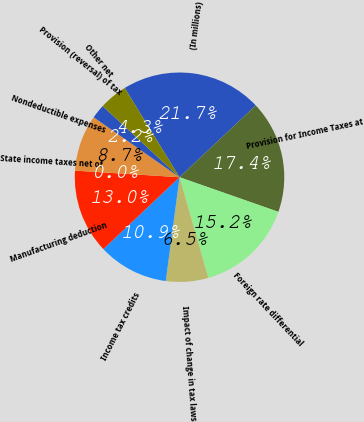Convert chart. <chart><loc_0><loc_0><loc_500><loc_500><pie_chart><fcel>(In millions)<fcel>Provision for Income Taxes at<fcel>Foreign rate differential<fcel>Impact of change in tax laws<fcel>Income tax credits<fcel>Manufacturing deduction<fcel>State income taxes net of<fcel>Nondeductible expenses<fcel>Provision (reversal) of tax<fcel>Other net<nl><fcel>21.74%<fcel>17.39%<fcel>15.22%<fcel>6.52%<fcel>10.87%<fcel>13.04%<fcel>0.0%<fcel>8.7%<fcel>2.18%<fcel>4.35%<nl></chart> 